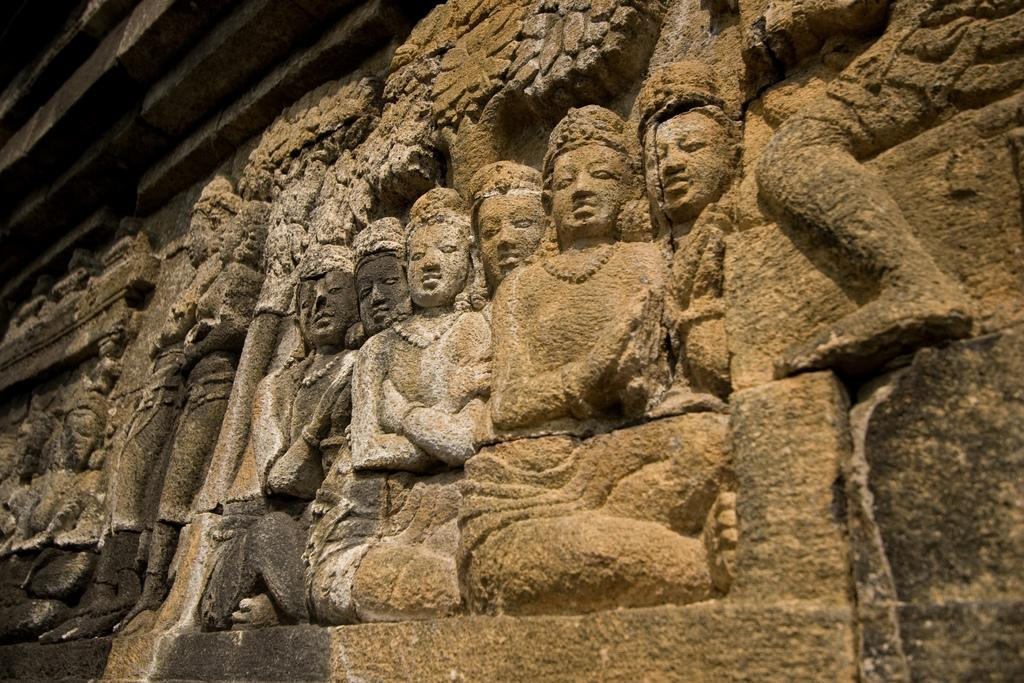What can be seen on the rock surface in the image? There are sculptures on the rock surface in the image. What colors are the sculptures? The sculptures are in black, brown, and cream colors. Where can the shop be found in the image? There is no shop present in the image; it features sculptures on a rock surface. What is the answer to the question that is not present in the image? There is no question or answer present in the image, as it only features sculptures on a rock surface. 